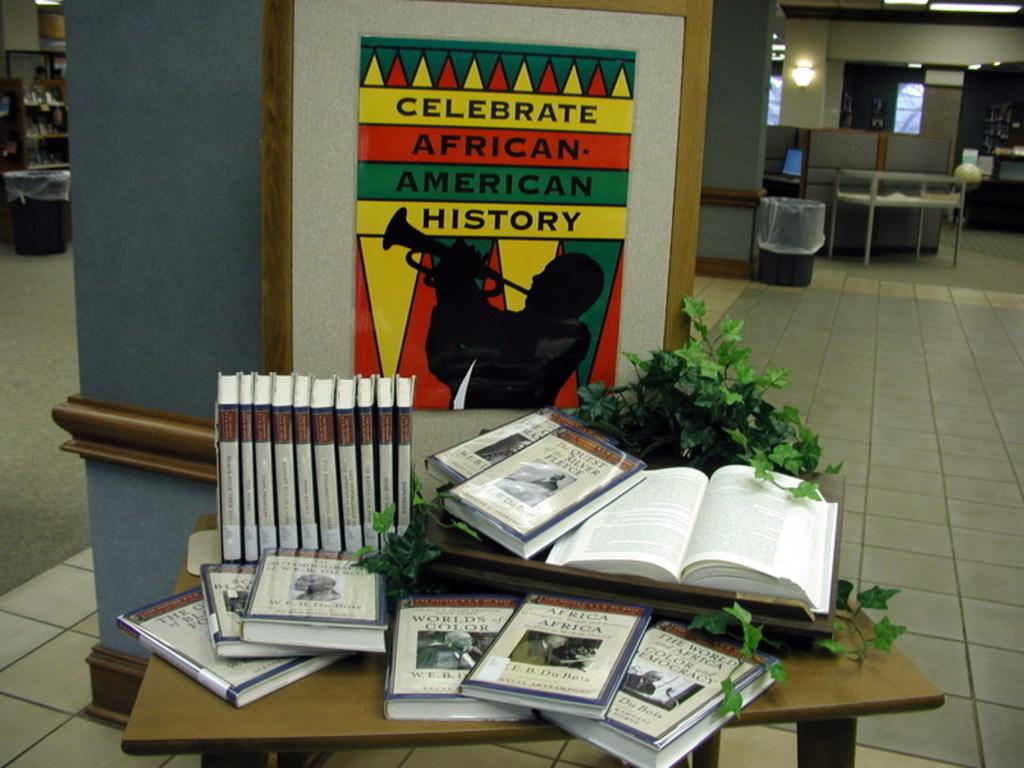<image>
Describe the image concisely. A copy of The Quest of the Silver Fleece sits on a table on top of some other books. 